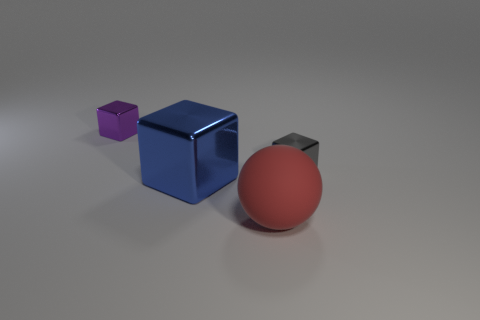There is a big object that is behind the rubber thing; what is its shape?
Ensure brevity in your answer.  Cube. What number of green things are spheres or small blocks?
Make the answer very short. 0. Do the red ball and the big blue block have the same material?
Provide a short and direct response. No. There is a gray shiny thing; what number of tiny blocks are to the left of it?
Keep it short and to the point. 1. There is a cube that is both to the right of the purple cube and to the left of the red matte ball; what material is it?
Keep it short and to the point. Metal. What number of spheres are big matte things or tiny gray metallic things?
Make the answer very short. 1. There is a purple thing that is the same shape as the gray metal thing; what is its material?
Your answer should be compact. Metal. The gray block that is made of the same material as the tiny purple thing is what size?
Ensure brevity in your answer.  Small. There is a big thing that is in front of the blue metal block; is it the same shape as the small metallic thing behind the small gray thing?
Keep it short and to the point. No. What is the color of the other large thing that is made of the same material as the gray object?
Provide a succinct answer. Blue. 